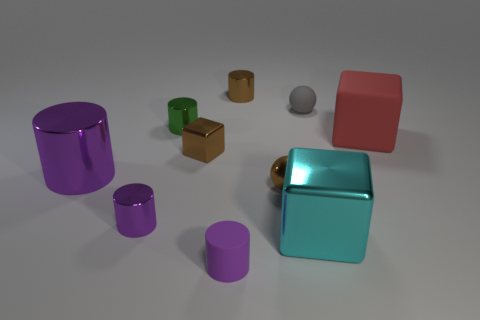Subtract all tiny metallic cubes. How many cubes are left? 2 Subtract all gray cubes. How many purple cylinders are left? 3 Subtract all cyan blocks. How many blocks are left? 2 Subtract all blue balls. Subtract all red blocks. How many balls are left? 2 Subtract all large matte cubes. Subtract all cyan shiny blocks. How many objects are left? 8 Add 4 cylinders. How many cylinders are left? 9 Add 10 tiny purple balls. How many tiny purple balls exist? 10 Subtract 1 brown balls. How many objects are left? 9 Subtract all cubes. How many objects are left? 7 